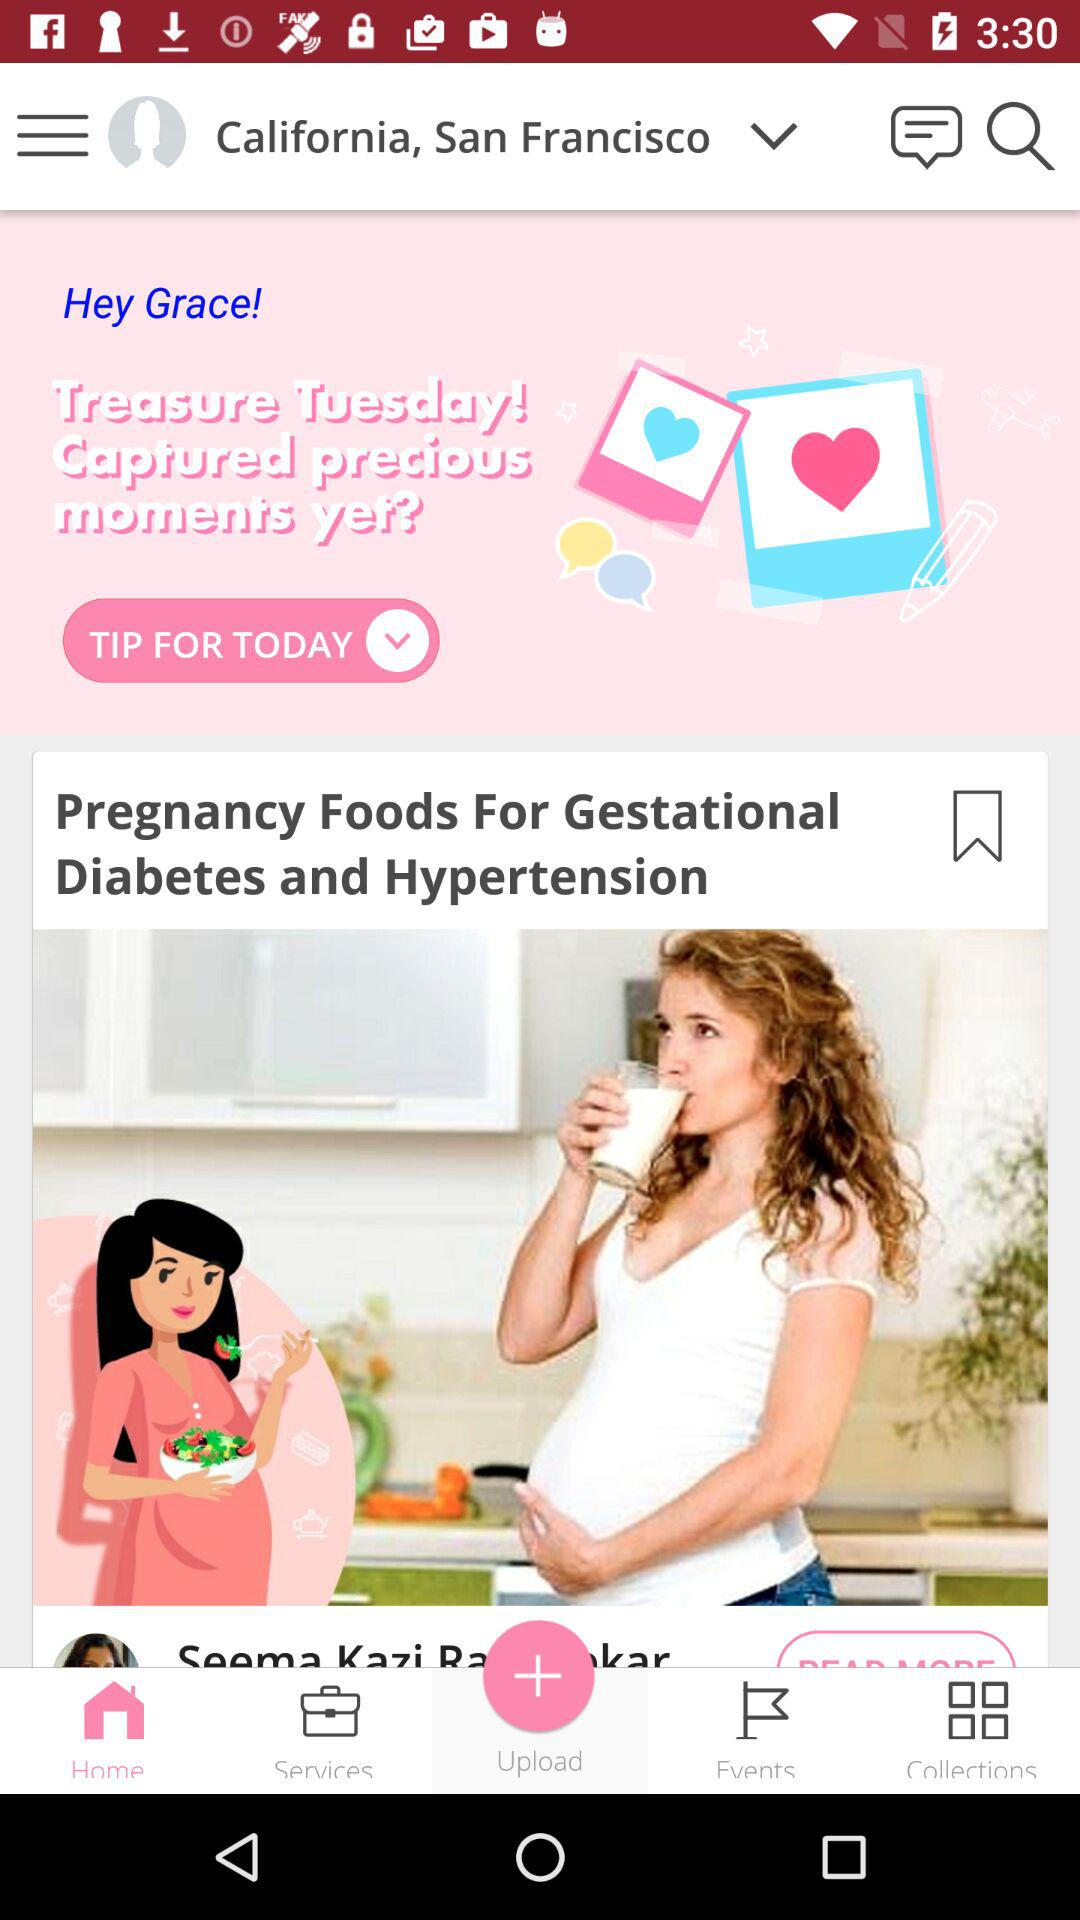Which tab is selected? The selected tab is "Home". 